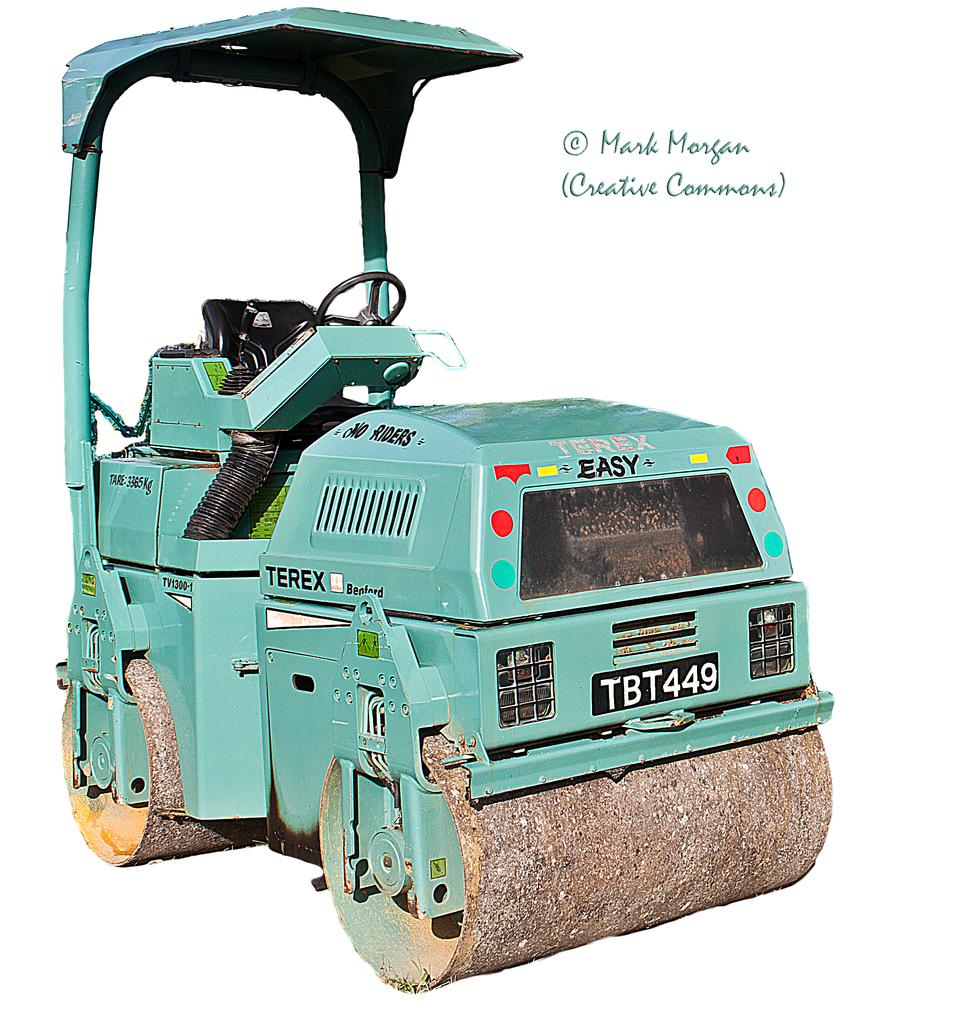What is the main subject of the image? There is a vehicle in the image. Can you describe any additional details about the vehicle? Unfortunately, the provided facts do not offer any additional details about the vehicle. What else can be seen in the image besides the vehicle? There is text visible in the image. What type of pies are being sold at the health clinic in the image? There is no mention of pies or a health clinic in the image, so it is not possible to answer that question. 